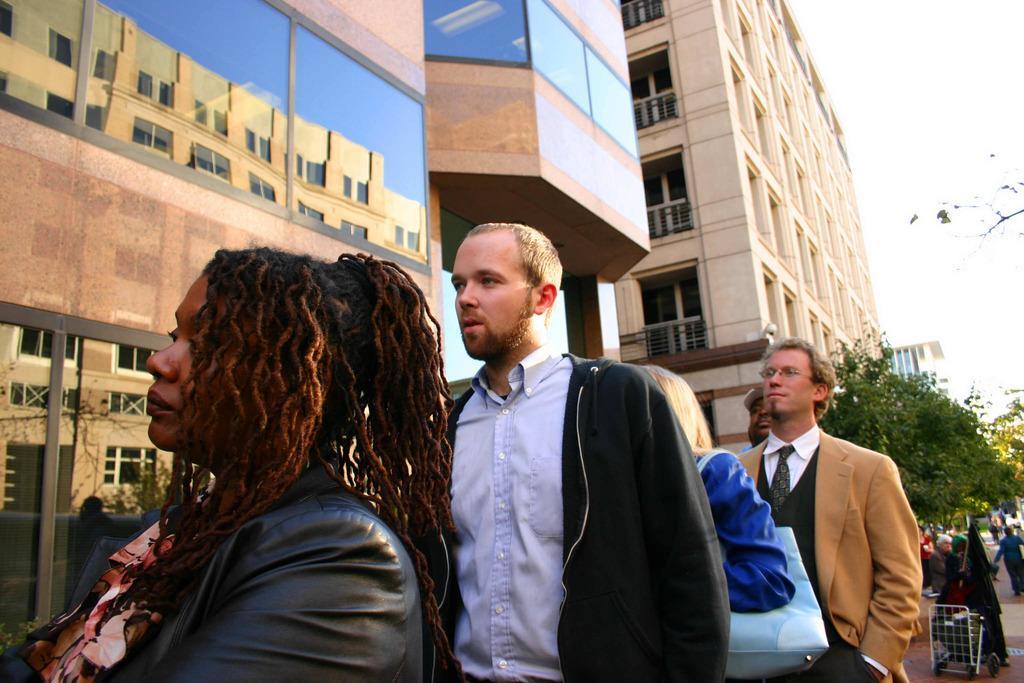Could you give a brief overview of what you see in this image? In this image there is a person wearing a black jacket is standing behind a woman. Behind him there is a person carrying a bag. Right side there is a person wearing suit and tie is standing. Behind him there are few persons standing on the floor. There are few trees. Behind there are few buildings. Right top there is sky. 